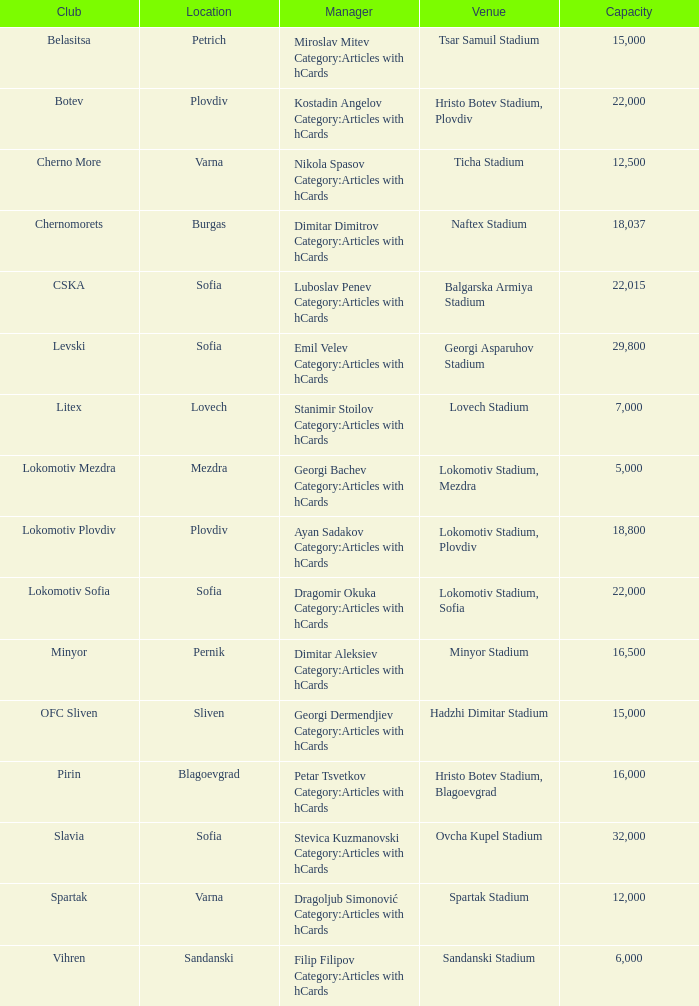What is the maximum capacity for the venue, ticha stadium, situated in varna? 12500.0. 